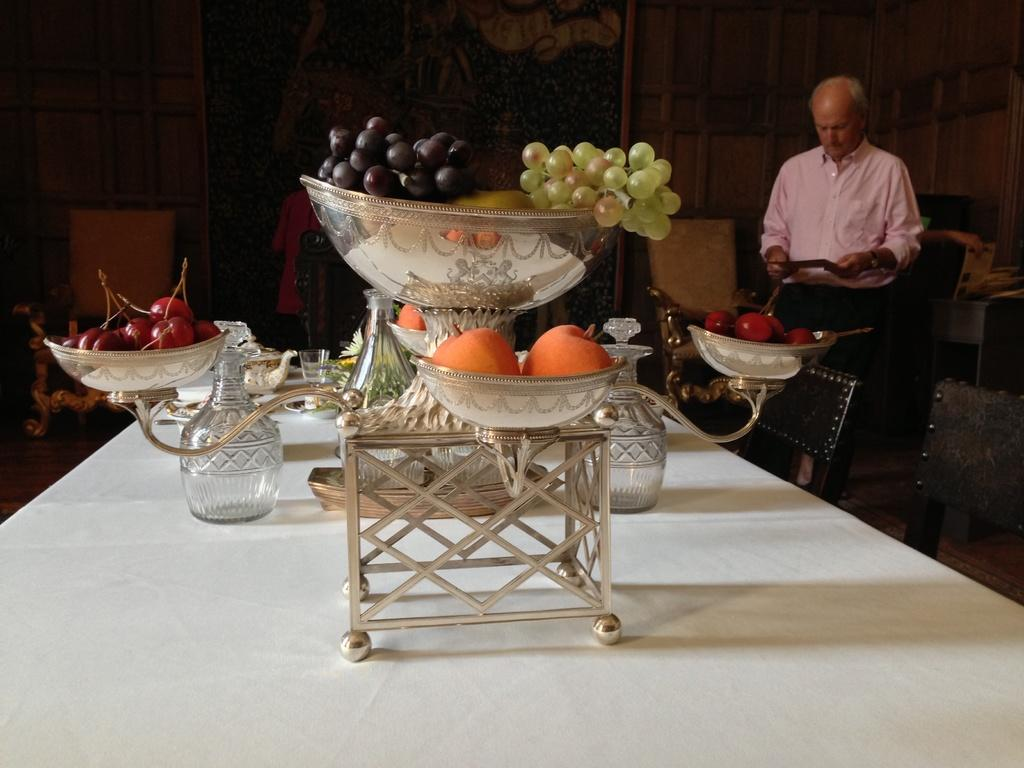What type of fruits can be seen on the dining table in the image? There are oranges, grapes, and cherry fruits on the dining table in the image. What is the man wearing in the image? The man is wearing a shirt in the image. Can you describe the seating arrangement in the image? There are chairs in the image. What type of prison can be seen in the background of the image? There is no prison present in the image; it features a dining table with fruits and a man standing nearby. Can you tell me how many robins are sitting on the chairs in the image? There are no robins present in the image; it features a dining table with fruits, a man, and chairs. 